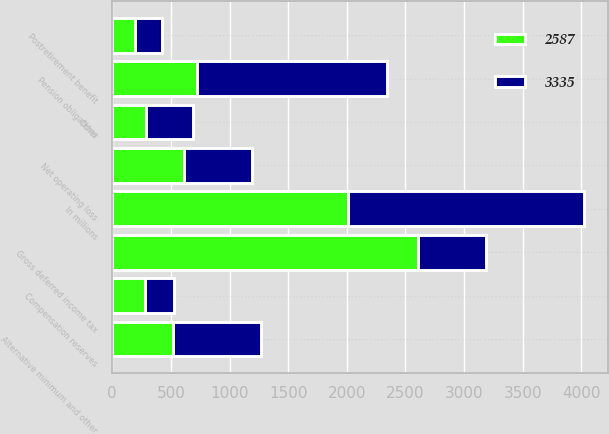<chart> <loc_0><loc_0><loc_500><loc_500><stacked_bar_chart><ecel><fcel>In millions<fcel>Postretirement benefit<fcel>Pension obligations<fcel>Alternative minimum and other<fcel>Net operating loss<fcel>Compensation reserves<fcel>Other<fcel>Gross deferred income tax<nl><fcel>2587<fcel>2013<fcel>193<fcel>725<fcel>515<fcel>610<fcel>281<fcel>284<fcel>2608<nl><fcel>3335<fcel>2012<fcel>229<fcel>1620<fcel>752<fcel>579<fcel>242<fcel>406<fcel>579<nl></chart> 